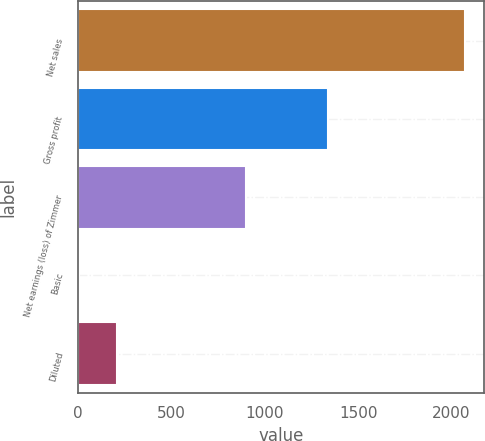<chart> <loc_0><loc_0><loc_500><loc_500><bar_chart><fcel>Net sales<fcel>Gross profit<fcel>Net earnings (loss) of Zimmer<fcel>Basic<fcel>Diluted<nl><fcel>2071<fcel>1339.6<fcel>901.1<fcel>4.42<fcel>211.08<nl></chart> 